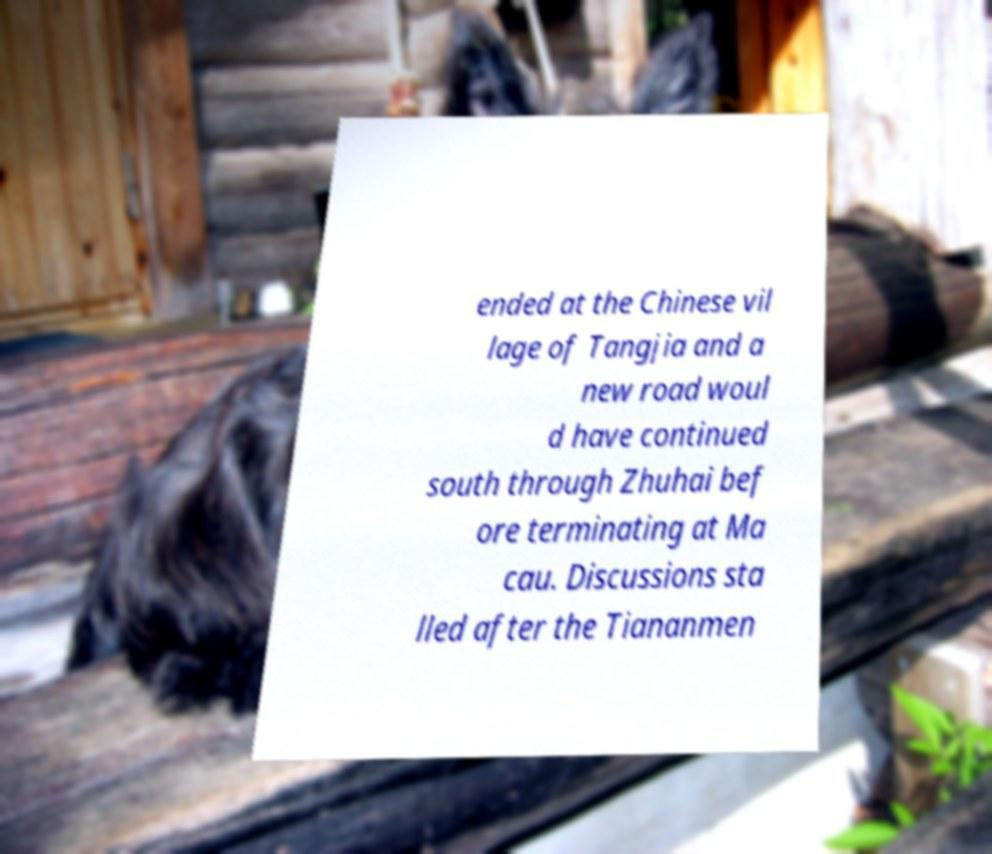Please read and relay the text visible in this image. What does it say? ended at the Chinese vil lage of Tangjia and a new road woul d have continued south through Zhuhai bef ore terminating at Ma cau. Discussions sta lled after the Tiananmen 